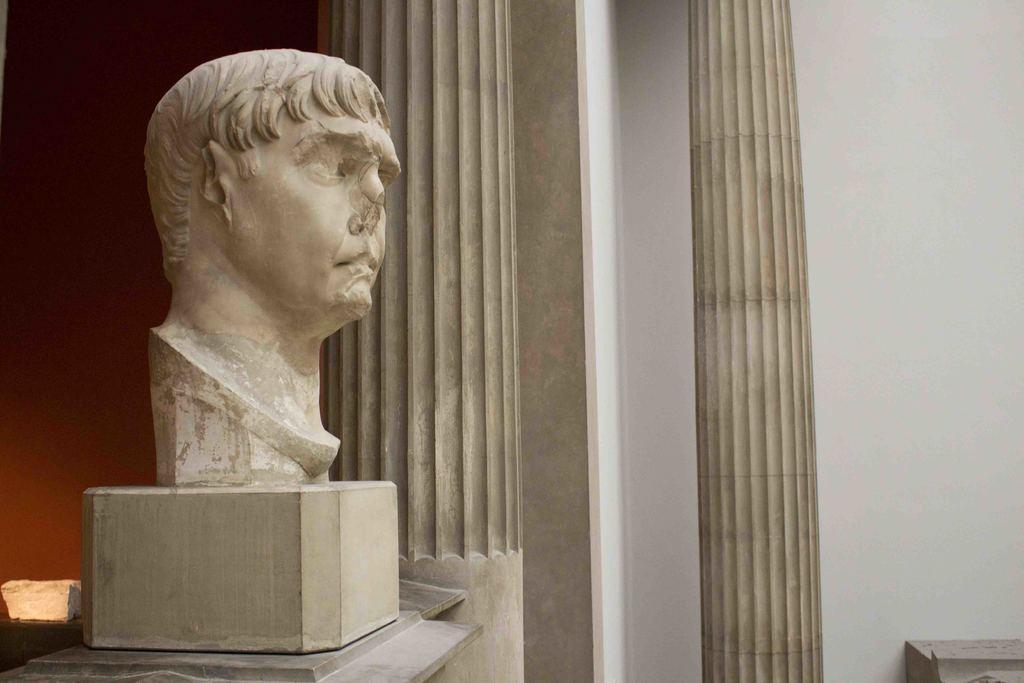Describe this image in one or two sentences. In this image we can see a statue on a stand. We can also see some pillars and a wall. 